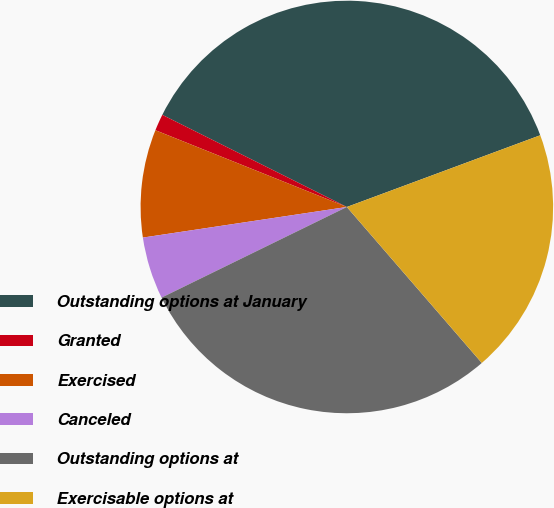Convert chart. <chart><loc_0><loc_0><loc_500><loc_500><pie_chart><fcel>Outstanding options at January<fcel>Granted<fcel>Exercised<fcel>Canceled<fcel>Outstanding options at<fcel>Exercisable options at<nl><fcel>36.98%<fcel>1.3%<fcel>8.44%<fcel>4.87%<fcel>29.11%<fcel>19.3%<nl></chart> 